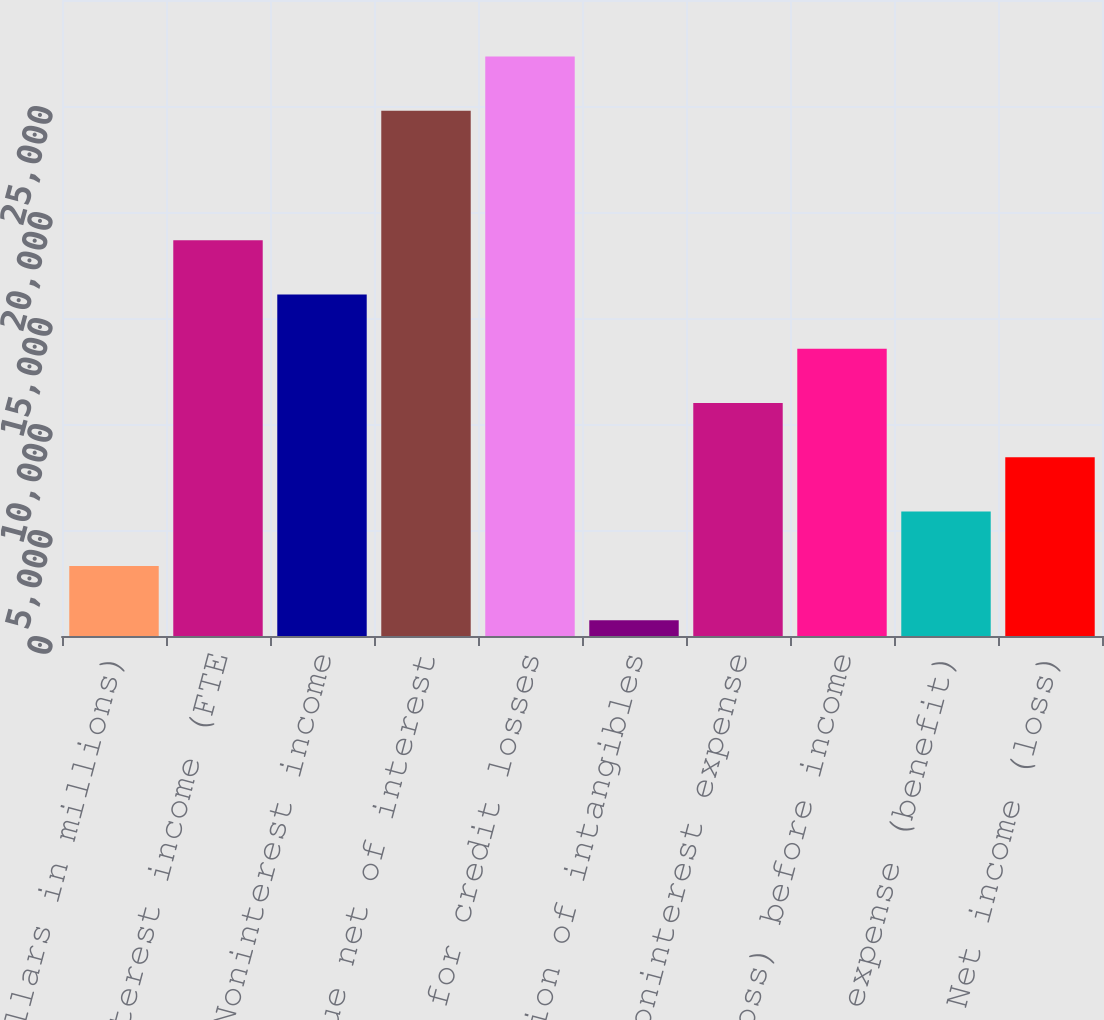Convert chart to OTSL. <chart><loc_0><loc_0><loc_500><loc_500><bar_chart><fcel>(Dollars in millions)<fcel>Net interest income (FTE<fcel>Noninterest income<fcel>Total revenue net of interest<fcel>Provision for credit losses<fcel>Amortization of intangibles<fcel>Other noninterest expense<fcel>Income (loss) before income<fcel>Income tax expense (benefit)<fcel>Net income (loss)<nl><fcel>3306.5<fcel>18669.5<fcel>16109<fcel>24777<fcel>27337.5<fcel>746<fcel>10988<fcel>13548.5<fcel>5867<fcel>8427.5<nl></chart> 